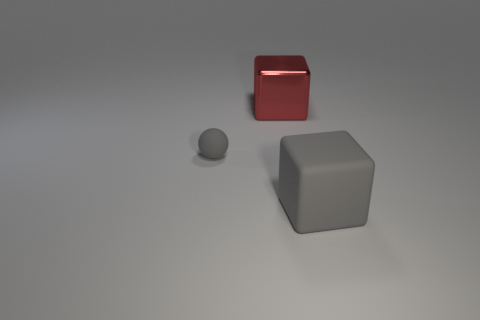What number of large objects are red metal things or rubber things?
Offer a terse response. 2. Is the number of purple things greater than the number of big gray blocks?
Offer a terse response. No. Does the big gray object have the same material as the small gray sphere?
Your answer should be very brief. Yes. Is there anything else that has the same material as the red block?
Offer a terse response. No. Is the number of large red metal cubes to the right of the big rubber block greater than the number of big green things?
Your response must be concise. No. Do the ball and the big rubber cube have the same color?
Ensure brevity in your answer.  Yes. What number of other objects have the same shape as the red thing?
Keep it short and to the point. 1. What size is the object that is the same material as the ball?
Your response must be concise. Large. What color is the object that is in front of the metal block and to the right of the small gray rubber sphere?
Keep it short and to the point. Gray. How many red cubes are the same size as the matte sphere?
Give a very brief answer. 0. 